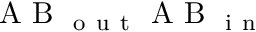Convert formula to latex. <formula><loc_0><loc_0><loc_500><loc_500>A B _ { o u t } A B _ { i n }</formula> 